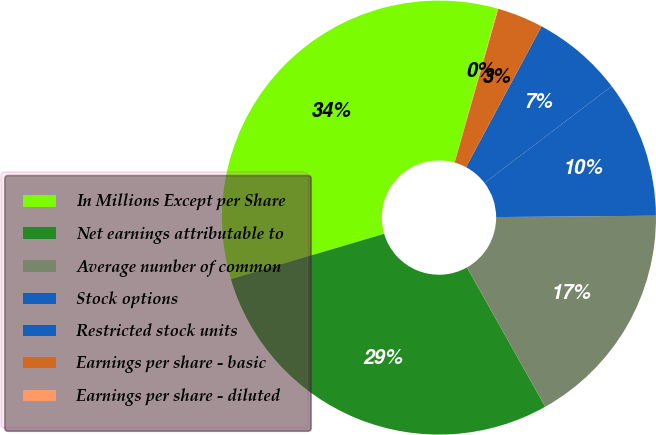<chart> <loc_0><loc_0><loc_500><loc_500><pie_chart><fcel>In Millions Except per Share<fcel>Net earnings attributable to<fcel>Average number of common<fcel>Stock options<fcel>Restricted stock units<fcel>Earnings per share - basic<fcel>Earnings per share - diluted<nl><fcel>33.93%<fcel>28.57%<fcel>16.99%<fcel>10.21%<fcel>6.82%<fcel>3.43%<fcel>0.05%<nl></chart> 